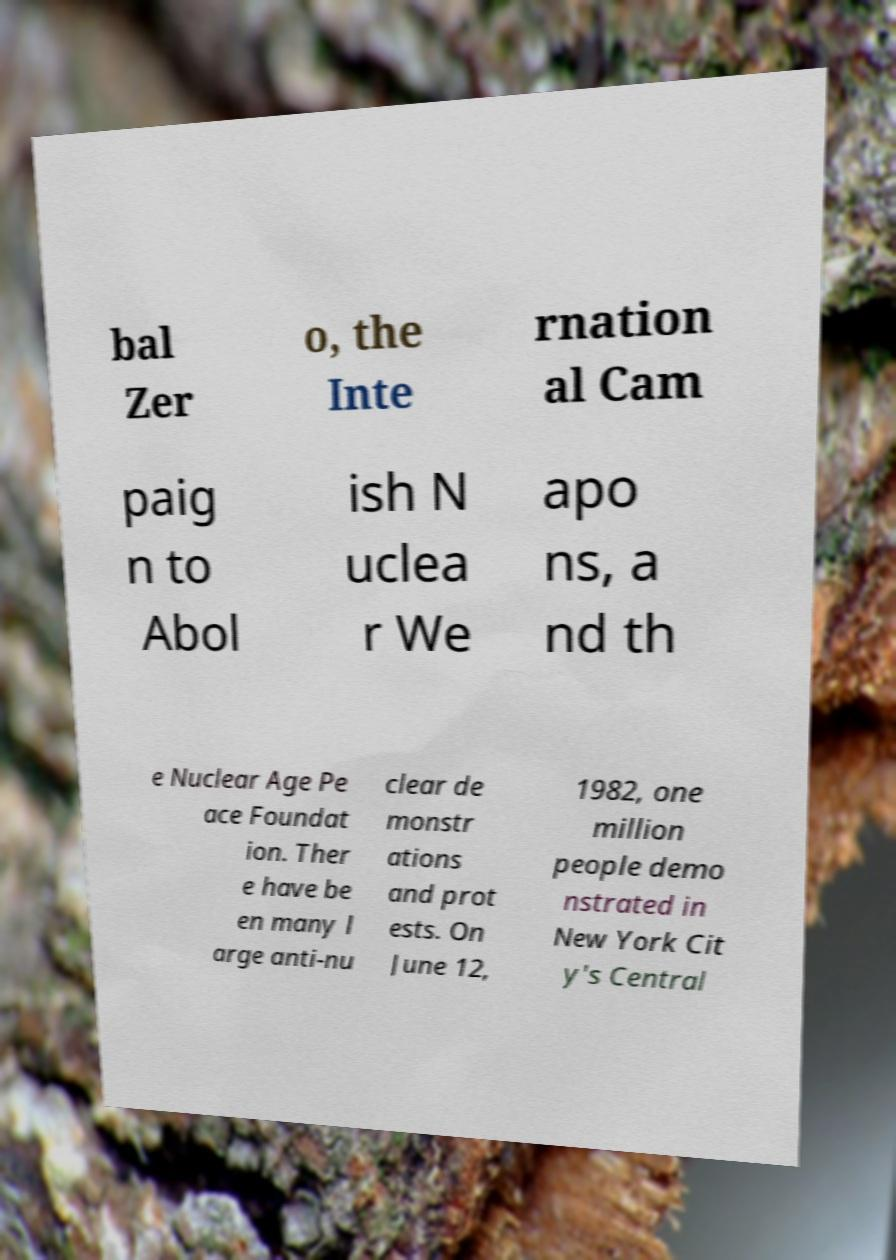Could you assist in decoding the text presented in this image and type it out clearly? bal Zer o, the Inte rnation al Cam paig n to Abol ish N uclea r We apo ns, a nd th e Nuclear Age Pe ace Foundat ion. Ther e have be en many l arge anti-nu clear de monstr ations and prot ests. On June 12, 1982, one million people demo nstrated in New York Cit y's Central 